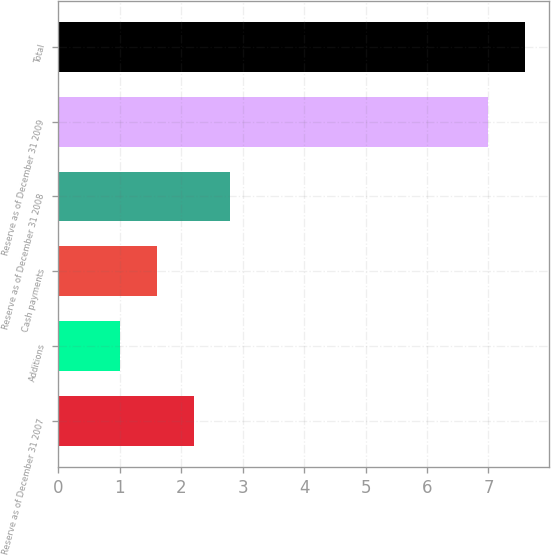Convert chart to OTSL. <chart><loc_0><loc_0><loc_500><loc_500><bar_chart><fcel>Reserve as of December 31 2007<fcel>Additions<fcel>Cash payments<fcel>Reserve as of December 31 2008<fcel>Reserve as of December 31 2009<fcel>Total<nl><fcel>2.2<fcel>1<fcel>1.6<fcel>2.8<fcel>7<fcel>7.6<nl></chart> 